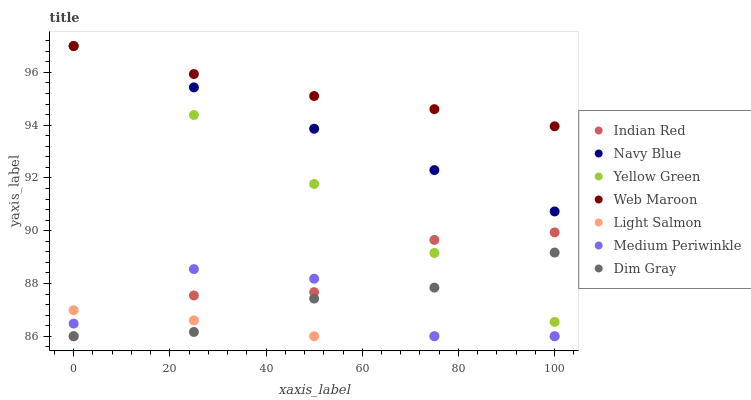Does Light Salmon have the minimum area under the curve?
Answer yes or no. Yes. Does Web Maroon have the maximum area under the curve?
Answer yes or no. Yes. Does Dim Gray have the minimum area under the curve?
Answer yes or no. No. Does Dim Gray have the maximum area under the curve?
Answer yes or no. No. Is Yellow Green the smoothest?
Answer yes or no. Yes. Is Medium Periwinkle the roughest?
Answer yes or no. Yes. Is Dim Gray the smoothest?
Answer yes or no. No. Is Dim Gray the roughest?
Answer yes or no. No. Does Light Salmon have the lowest value?
Answer yes or no. Yes. Does Yellow Green have the lowest value?
Answer yes or no. No. Does Web Maroon have the highest value?
Answer yes or no. Yes. Does Dim Gray have the highest value?
Answer yes or no. No. Is Dim Gray less than Web Maroon?
Answer yes or no. Yes. Is Yellow Green greater than Light Salmon?
Answer yes or no. Yes. Does Yellow Green intersect Dim Gray?
Answer yes or no. Yes. Is Yellow Green less than Dim Gray?
Answer yes or no. No. Is Yellow Green greater than Dim Gray?
Answer yes or no. No. Does Dim Gray intersect Web Maroon?
Answer yes or no. No. 